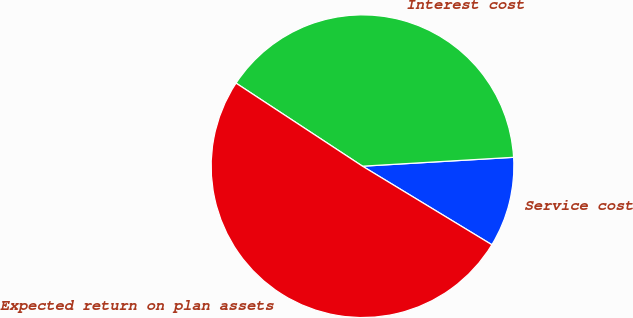Convert chart to OTSL. <chart><loc_0><loc_0><loc_500><loc_500><pie_chart><fcel>Service cost<fcel>Interest cost<fcel>Expected return on plan assets<nl><fcel>9.62%<fcel>39.81%<fcel>50.56%<nl></chart> 